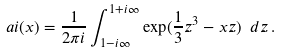<formula> <loc_0><loc_0><loc_500><loc_500>\ a i ( x ) = \frac { 1 } { 2 \pi i } \int _ { 1 - i \infty } ^ { 1 + i \infty } \exp ( \frac { 1 } { 3 } z ^ { 3 } - x z ) \ d z \, .</formula> 